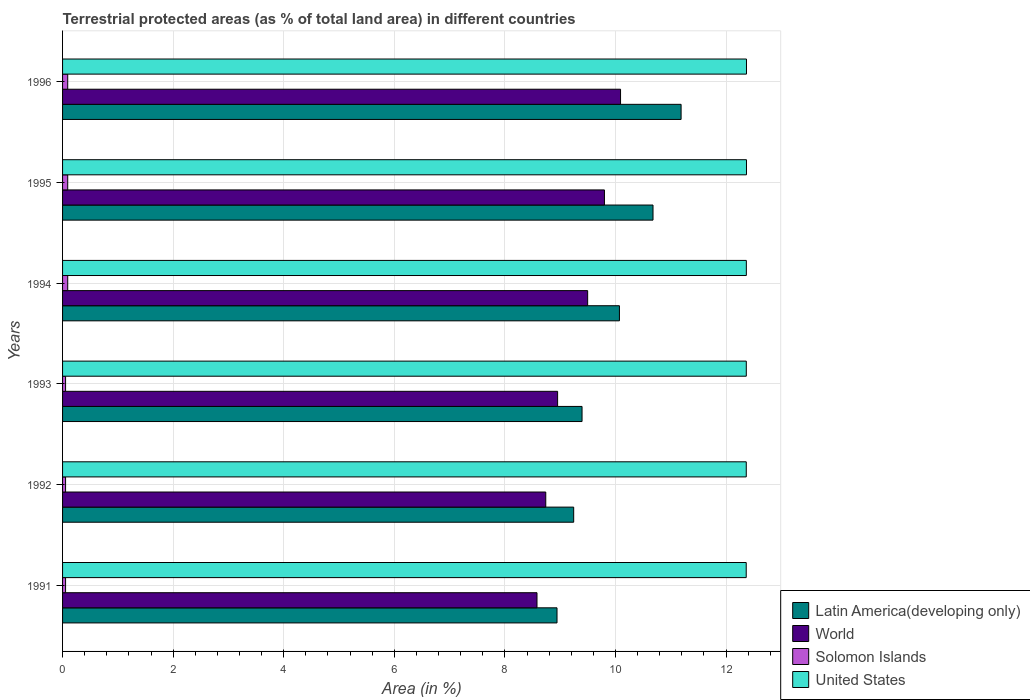How many different coloured bars are there?
Offer a terse response. 4. How many groups of bars are there?
Ensure brevity in your answer.  6. Are the number of bars per tick equal to the number of legend labels?
Provide a succinct answer. Yes. Are the number of bars on each tick of the Y-axis equal?
Offer a terse response. Yes. How many bars are there on the 6th tick from the top?
Provide a succinct answer. 4. What is the label of the 5th group of bars from the top?
Offer a terse response. 1992. What is the percentage of terrestrial protected land in United States in 1992?
Make the answer very short. 12.36. Across all years, what is the maximum percentage of terrestrial protected land in United States?
Offer a very short reply. 12.37. Across all years, what is the minimum percentage of terrestrial protected land in Latin America(developing only)?
Offer a very short reply. 8.94. What is the total percentage of terrestrial protected land in World in the graph?
Ensure brevity in your answer.  55.66. What is the difference between the percentage of terrestrial protected land in Latin America(developing only) in 1992 and that in 1993?
Give a very brief answer. -0.15. What is the difference between the percentage of terrestrial protected land in Solomon Islands in 1994 and the percentage of terrestrial protected land in Latin America(developing only) in 1993?
Make the answer very short. -9.3. What is the average percentage of terrestrial protected land in World per year?
Keep it short and to the point. 9.28. In the year 1994, what is the difference between the percentage of terrestrial protected land in Latin America(developing only) and percentage of terrestrial protected land in Solomon Islands?
Give a very brief answer. 9.98. In how many years, is the percentage of terrestrial protected land in World greater than 1.6 %?
Give a very brief answer. 6. What is the ratio of the percentage of terrestrial protected land in World in 1994 to that in 1995?
Offer a very short reply. 0.97. What is the difference between the highest and the second highest percentage of terrestrial protected land in Latin America(developing only)?
Keep it short and to the point. 0.51. What is the difference between the highest and the lowest percentage of terrestrial protected land in Latin America(developing only)?
Your response must be concise. 2.24. In how many years, is the percentage of terrestrial protected land in Solomon Islands greater than the average percentage of terrestrial protected land in Solomon Islands taken over all years?
Give a very brief answer. 3. What does the 2nd bar from the top in 1994 represents?
Ensure brevity in your answer.  Solomon Islands. What does the 4th bar from the bottom in 1996 represents?
Keep it short and to the point. United States. How many bars are there?
Provide a short and direct response. 24. Are all the bars in the graph horizontal?
Ensure brevity in your answer.  Yes. What is the difference between two consecutive major ticks on the X-axis?
Your answer should be very brief. 2. Are the values on the major ticks of X-axis written in scientific E-notation?
Make the answer very short. No. What is the title of the graph?
Offer a very short reply. Terrestrial protected areas (as % of total land area) in different countries. What is the label or title of the X-axis?
Your answer should be compact. Area (in %). What is the label or title of the Y-axis?
Your answer should be compact. Years. What is the Area (in %) in Latin America(developing only) in 1991?
Your response must be concise. 8.94. What is the Area (in %) of World in 1991?
Provide a succinct answer. 8.58. What is the Area (in %) of Solomon Islands in 1991?
Offer a very short reply. 0.05. What is the Area (in %) in United States in 1991?
Provide a succinct answer. 12.36. What is the Area (in %) of Latin America(developing only) in 1992?
Provide a short and direct response. 9.24. What is the Area (in %) of World in 1992?
Make the answer very short. 8.74. What is the Area (in %) in Solomon Islands in 1992?
Provide a short and direct response. 0.05. What is the Area (in %) of United States in 1992?
Your answer should be compact. 12.36. What is the Area (in %) of Latin America(developing only) in 1993?
Your answer should be very brief. 9.39. What is the Area (in %) in World in 1993?
Your response must be concise. 8.95. What is the Area (in %) in Solomon Islands in 1993?
Offer a very short reply. 0.05. What is the Area (in %) of United States in 1993?
Make the answer very short. 12.37. What is the Area (in %) of Latin America(developing only) in 1994?
Give a very brief answer. 10.07. What is the Area (in %) of World in 1994?
Your response must be concise. 9.5. What is the Area (in %) in Solomon Islands in 1994?
Ensure brevity in your answer.  0.09. What is the Area (in %) of United States in 1994?
Keep it short and to the point. 12.37. What is the Area (in %) of Latin America(developing only) in 1995?
Provide a short and direct response. 10.68. What is the Area (in %) in World in 1995?
Offer a terse response. 9.8. What is the Area (in %) of Solomon Islands in 1995?
Keep it short and to the point. 0.09. What is the Area (in %) in United States in 1995?
Make the answer very short. 12.37. What is the Area (in %) in Latin America(developing only) in 1996?
Give a very brief answer. 11.19. What is the Area (in %) of World in 1996?
Provide a short and direct response. 10.09. What is the Area (in %) in Solomon Islands in 1996?
Provide a short and direct response. 0.09. What is the Area (in %) in United States in 1996?
Keep it short and to the point. 12.37. Across all years, what is the maximum Area (in %) in Latin America(developing only)?
Offer a terse response. 11.19. Across all years, what is the maximum Area (in %) in World?
Keep it short and to the point. 10.09. Across all years, what is the maximum Area (in %) of Solomon Islands?
Ensure brevity in your answer.  0.09. Across all years, what is the maximum Area (in %) in United States?
Your answer should be very brief. 12.37. Across all years, what is the minimum Area (in %) of Latin America(developing only)?
Offer a terse response. 8.94. Across all years, what is the minimum Area (in %) in World?
Offer a terse response. 8.58. Across all years, what is the minimum Area (in %) of Solomon Islands?
Ensure brevity in your answer.  0.05. Across all years, what is the minimum Area (in %) in United States?
Your answer should be compact. 12.36. What is the total Area (in %) of Latin America(developing only) in the graph?
Provide a succinct answer. 59.52. What is the total Area (in %) in World in the graph?
Make the answer very short. 55.66. What is the total Area (in %) in Solomon Islands in the graph?
Make the answer very short. 0.44. What is the total Area (in %) of United States in the graph?
Offer a terse response. 74.2. What is the difference between the Area (in %) of Latin America(developing only) in 1991 and that in 1992?
Your response must be concise. -0.3. What is the difference between the Area (in %) in World in 1991 and that in 1992?
Your answer should be compact. -0.16. What is the difference between the Area (in %) of Solomon Islands in 1991 and that in 1992?
Make the answer very short. 0. What is the difference between the Area (in %) in United States in 1991 and that in 1992?
Your answer should be compact. -0. What is the difference between the Area (in %) in Latin America(developing only) in 1991 and that in 1993?
Your response must be concise. -0.45. What is the difference between the Area (in %) of World in 1991 and that in 1993?
Offer a terse response. -0.37. What is the difference between the Area (in %) in United States in 1991 and that in 1993?
Offer a terse response. -0. What is the difference between the Area (in %) in Latin America(developing only) in 1991 and that in 1994?
Offer a very short reply. -1.13. What is the difference between the Area (in %) in World in 1991 and that in 1994?
Ensure brevity in your answer.  -0.92. What is the difference between the Area (in %) in Solomon Islands in 1991 and that in 1994?
Make the answer very short. -0.04. What is the difference between the Area (in %) in United States in 1991 and that in 1994?
Provide a succinct answer. -0. What is the difference between the Area (in %) of Latin America(developing only) in 1991 and that in 1995?
Your answer should be very brief. -1.74. What is the difference between the Area (in %) of World in 1991 and that in 1995?
Offer a very short reply. -1.22. What is the difference between the Area (in %) in Solomon Islands in 1991 and that in 1995?
Provide a succinct answer. -0.04. What is the difference between the Area (in %) of United States in 1991 and that in 1995?
Keep it short and to the point. -0. What is the difference between the Area (in %) of Latin America(developing only) in 1991 and that in 1996?
Your answer should be compact. -2.24. What is the difference between the Area (in %) in World in 1991 and that in 1996?
Your answer should be compact. -1.51. What is the difference between the Area (in %) in Solomon Islands in 1991 and that in 1996?
Your answer should be very brief. -0.04. What is the difference between the Area (in %) of United States in 1991 and that in 1996?
Provide a succinct answer. -0. What is the difference between the Area (in %) in Latin America(developing only) in 1992 and that in 1993?
Make the answer very short. -0.15. What is the difference between the Area (in %) in World in 1992 and that in 1993?
Make the answer very short. -0.21. What is the difference between the Area (in %) of Solomon Islands in 1992 and that in 1993?
Your answer should be compact. 0. What is the difference between the Area (in %) in United States in 1992 and that in 1993?
Your answer should be compact. -0. What is the difference between the Area (in %) in Latin America(developing only) in 1992 and that in 1994?
Give a very brief answer. -0.83. What is the difference between the Area (in %) of World in 1992 and that in 1994?
Ensure brevity in your answer.  -0.76. What is the difference between the Area (in %) of Solomon Islands in 1992 and that in 1994?
Provide a short and direct response. -0.04. What is the difference between the Area (in %) of United States in 1992 and that in 1994?
Ensure brevity in your answer.  -0. What is the difference between the Area (in %) in Latin America(developing only) in 1992 and that in 1995?
Your response must be concise. -1.43. What is the difference between the Area (in %) of World in 1992 and that in 1995?
Ensure brevity in your answer.  -1.06. What is the difference between the Area (in %) of Solomon Islands in 1992 and that in 1995?
Offer a terse response. -0.04. What is the difference between the Area (in %) of United States in 1992 and that in 1995?
Provide a short and direct response. -0. What is the difference between the Area (in %) in Latin America(developing only) in 1992 and that in 1996?
Provide a short and direct response. -1.94. What is the difference between the Area (in %) in World in 1992 and that in 1996?
Give a very brief answer. -1.35. What is the difference between the Area (in %) of Solomon Islands in 1992 and that in 1996?
Your answer should be compact. -0.04. What is the difference between the Area (in %) of United States in 1992 and that in 1996?
Offer a very short reply. -0. What is the difference between the Area (in %) of Latin America(developing only) in 1993 and that in 1994?
Give a very brief answer. -0.68. What is the difference between the Area (in %) in World in 1993 and that in 1994?
Ensure brevity in your answer.  -0.54. What is the difference between the Area (in %) of Solomon Islands in 1993 and that in 1994?
Give a very brief answer. -0.04. What is the difference between the Area (in %) of United States in 1993 and that in 1994?
Give a very brief answer. -0. What is the difference between the Area (in %) of Latin America(developing only) in 1993 and that in 1995?
Ensure brevity in your answer.  -1.28. What is the difference between the Area (in %) of World in 1993 and that in 1995?
Offer a very short reply. -0.85. What is the difference between the Area (in %) in Solomon Islands in 1993 and that in 1995?
Provide a short and direct response. -0.04. What is the difference between the Area (in %) of United States in 1993 and that in 1995?
Offer a terse response. -0. What is the difference between the Area (in %) of Latin America(developing only) in 1993 and that in 1996?
Keep it short and to the point. -1.79. What is the difference between the Area (in %) of World in 1993 and that in 1996?
Your response must be concise. -1.14. What is the difference between the Area (in %) of Solomon Islands in 1993 and that in 1996?
Keep it short and to the point. -0.04. What is the difference between the Area (in %) in United States in 1993 and that in 1996?
Provide a short and direct response. -0. What is the difference between the Area (in %) of Latin America(developing only) in 1994 and that in 1995?
Offer a terse response. -0.61. What is the difference between the Area (in %) in World in 1994 and that in 1995?
Ensure brevity in your answer.  -0.3. What is the difference between the Area (in %) in United States in 1994 and that in 1995?
Make the answer very short. -0. What is the difference between the Area (in %) of Latin America(developing only) in 1994 and that in 1996?
Provide a succinct answer. -1.11. What is the difference between the Area (in %) of World in 1994 and that in 1996?
Offer a terse response. -0.59. What is the difference between the Area (in %) of United States in 1994 and that in 1996?
Offer a terse response. -0. What is the difference between the Area (in %) in Latin America(developing only) in 1995 and that in 1996?
Provide a succinct answer. -0.51. What is the difference between the Area (in %) in World in 1995 and that in 1996?
Give a very brief answer. -0.29. What is the difference between the Area (in %) of United States in 1995 and that in 1996?
Ensure brevity in your answer.  -0. What is the difference between the Area (in %) in Latin America(developing only) in 1991 and the Area (in %) in World in 1992?
Your answer should be very brief. 0.2. What is the difference between the Area (in %) of Latin America(developing only) in 1991 and the Area (in %) of Solomon Islands in 1992?
Offer a terse response. 8.89. What is the difference between the Area (in %) of Latin America(developing only) in 1991 and the Area (in %) of United States in 1992?
Provide a short and direct response. -3.42. What is the difference between the Area (in %) in World in 1991 and the Area (in %) in Solomon Islands in 1992?
Your answer should be very brief. 8.53. What is the difference between the Area (in %) in World in 1991 and the Area (in %) in United States in 1992?
Provide a succinct answer. -3.78. What is the difference between the Area (in %) of Solomon Islands in 1991 and the Area (in %) of United States in 1992?
Make the answer very short. -12.31. What is the difference between the Area (in %) in Latin America(developing only) in 1991 and the Area (in %) in World in 1993?
Provide a short and direct response. -0.01. What is the difference between the Area (in %) of Latin America(developing only) in 1991 and the Area (in %) of Solomon Islands in 1993?
Keep it short and to the point. 8.89. What is the difference between the Area (in %) in Latin America(developing only) in 1991 and the Area (in %) in United States in 1993?
Your answer should be very brief. -3.42. What is the difference between the Area (in %) in World in 1991 and the Area (in %) in Solomon Islands in 1993?
Keep it short and to the point. 8.53. What is the difference between the Area (in %) in World in 1991 and the Area (in %) in United States in 1993?
Keep it short and to the point. -3.79. What is the difference between the Area (in %) in Solomon Islands in 1991 and the Area (in %) in United States in 1993?
Keep it short and to the point. -12.31. What is the difference between the Area (in %) in Latin America(developing only) in 1991 and the Area (in %) in World in 1994?
Give a very brief answer. -0.55. What is the difference between the Area (in %) of Latin America(developing only) in 1991 and the Area (in %) of Solomon Islands in 1994?
Your response must be concise. 8.85. What is the difference between the Area (in %) of Latin America(developing only) in 1991 and the Area (in %) of United States in 1994?
Ensure brevity in your answer.  -3.42. What is the difference between the Area (in %) in World in 1991 and the Area (in %) in Solomon Islands in 1994?
Offer a very short reply. 8.49. What is the difference between the Area (in %) of World in 1991 and the Area (in %) of United States in 1994?
Provide a succinct answer. -3.79. What is the difference between the Area (in %) of Solomon Islands in 1991 and the Area (in %) of United States in 1994?
Provide a short and direct response. -12.31. What is the difference between the Area (in %) of Latin America(developing only) in 1991 and the Area (in %) of World in 1995?
Give a very brief answer. -0.86. What is the difference between the Area (in %) in Latin America(developing only) in 1991 and the Area (in %) in Solomon Islands in 1995?
Offer a very short reply. 8.85. What is the difference between the Area (in %) in Latin America(developing only) in 1991 and the Area (in %) in United States in 1995?
Offer a terse response. -3.43. What is the difference between the Area (in %) in World in 1991 and the Area (in %) in Solomon Islands in 1995?
Keep it short and to the point. 8.49. What is the difference between the Area (in %) of World in 1991 and the Area (in %) of United States in 1995?
Provide a succinct answer. -3.79. What is the difference between the Area (in %) in Solomon Islands in 1991 and the Area (in %) in United States in 1995?
Ensure brevity in your answer.  -12.31. What is the difference between the Area (in %) of Latin America(developing only) in 1991 and the Area (in %) of World in 1996?
Ensure brevity in your answer.  -1.15. What is the difference between the Area (in %) in Latin America(developing only) in 1991 and the Area (in %) in Solomon Islands in 1996?
Offer a terse response. 8.85. What is the difference between the Area (in %) of Latin America(developing only) in 1991 and the Area (in %) of United States in 1996?
Make the answer very short. -3.43. What is the difference between the Area (in %) in World in 1991 and the Area (in %) in Solomon Islands in 1996?
Give a very brief answer. 8.49. What is the difference between the Area (in %) of World in 1991 and the Area (in %) of United States in 1996?
Keep it short and to the point. -3.79. What is the difference between the Area (in %) in Solomon Islands in 1991 and the Area (in %) in United States in 1996?
Offer a terse response. -12.31. What is the difference between the Area (in %) in Latin America(developing only) in 1992 and the Area (in %) in World in 1993?
Give a very brief answer. 0.29. What is the difference between the Area (in %) in Latin America(developing only) in 1992 and the Area (in %) in Solomon Islands in 1993?
Provide a short and direct response. 9.19. What is the difference between the Area (in %) in Latin America(developing only) in 1992 and the Area (in %) in United States in 1993?
Provide a succinct answer. -3.12. What is the difference between the Area (in %) in World in 1992 and the Area (in %) in Solomon Islands in 1993?
Give a very brief answer. 8.68. What is the difference between the Area (in %) in World in 1992 and the Area (in %) in United States in 1993?
Offer a terse response. -3.63. What is the difference between the Area (in %) in Solomon Islands in 1992 and the Area (in %) in United States in 1993?
Offer a very short reply. -12.31. What is the difference between the Area (in %) of Latin America(developing only) in 1992 and the Area (in %) of World in 1994?
Your answer should be very brief. -0.25. What is the difference between the Area (in %) in Latin America(developing only) in 1992 and the Area (in %) in Solomon Islands in 1994?
Make the answer very short. 9.15. What is the difference between the Area (in %) in Latin America(developing only) in 1992 and the Area (in %) in United States in 1994?
Keep it short and to the point. -3.12. What is the difference between the Area (in %) of World in 1992 and the Area (in %) of Solomon Islands in 1994?
Offer a terse response. 8.65. What is the difference between the Area (in %) of World in 1992 and the Area (in %) of United States in 1994?
Your response must be concise. -3.63. What is the difference between the Area (in %) in Solomon Islands in 1992 and the Area (in %) in United States in 1994?
Your answer should be very brief. -12.31. What is the difference between the Area (in %) in Latin America(developing only) in 1992 and the Area (in %) in World in 1995?
Provide a short and direct response. -0.56. What is the difference between the Area (in %) in Latin America(developing only) in 1992 and the Area (in %) in Solomon Islands in 1995?
Your answer should be compact. 9.15. What is the difference between the Area (in %) of Latin America(developing only) in 1992 and the Area (in %) of United States in 1995?
Your answer should be compact. -3.13. What is the difference between the Area (in %) in World in 1992 and the Area (in %) in Solomon Islands in 1995?
Provide a short and direct response. 8.65. What is the difference between the Area (in %) of World in 1992 and the Area (in %) of United States in 1995?
Give a very brief answer. -3.63. What is the difference between the Area (in %) in Solomon Islands in 1992 and the Area (in %) in United States in 1995?
Make the answer very short. -12.31. What is the difference between the Area (in %) of Latin America(developing only) in 1992 and the Area (in %) of World in 1996?
Offer a terse response. -0.85. What is the difference between the Area (in %) in Latin America(developing only) in 1992 and the Area (in %) in Solomon Islands in 1996?
Provide a succinct answer. 9.15. What is the difference between the Area (in %) of Latin America(developing only) in 1992 and the Area (in %) of United States in 1996?
Offer a terse response. -3.13. What is the difference between the Area (in %) of World in 1992 and the Area (in %) of Solomon Islands in 1996?
Provide a short and direct response. 8.65. What is the difference between the Area (in %) in World in 1992 and the Area (in %) in United States in 1996?
Provide a short and direct response. -3.63. What is the difference between the Area (in %) in Solomon Islands in 1992 and the Area (in %) in United States in 1996?
Your answer should be very brief. -12.31. What is the difference between the Area (in %) of Latin America(developing only) in 1993 and the Area (in %) of World in 1994?
Provide a succinct answer. -0.1. What is the difference between the Area (in %) of Latin America(developing only) in 1993 and the Area (in %) of Solomon Islands in 1994?
Offer a terse response. 9.3. What is the difference between the Area (in %) of Latin America(developing only) in 1993 and the Area (in %) of United States in 1994?
Keep it short and to the point. -2.97. What is the difference between the Area (in %) in World in 1993 and the Area (in %) in Solomon Islands in 1994?
Make the answer very short. 8.86. What is the difference between the Area (in %) of World in 1993 and the Area (in %) of United States in 1994?
Offer a terse response. -3.41. What is the difference between the Area (in %) of Solomon Islands in 1993 and the Area (in %) of United States in 1994?
Your response must be concise. -12.31. What is the difference between the Area (in %) in Latin America(developing only) in 1993 and the Area (in %) in World in 1995?
Your response must be concise. -0.41. What is the difference between the Area (in %) of Latin America(developing only) in 1993 and the Area (in %) of Solomon Islands in 1995?
Your answer should be very brief. 9.3. What is the difference between the Area (in %) in Latin America(developing only) in 1993 and the Area (in %) in United States in 1995?
Ensure brevity in your answer.  -2.97. What is the difference between the Area (in %) in World in 1993 and the Area (in %) in Solomon Islands in 1995?
Offer a very short reply. 8.86. What is the difference between the Area (in %) in World in 1993 and the Area (in %) in United States in 1995?
Ensure brevity in your answer.  -3.42. What is the difference between the Area (in %) in Solomon Islands in 1993 and the Area (in %) in United States in 1995?
Keep it short and to the point. -12.31. What is the difference between the Area (in %) of Latin America(developing only) in 1993 and the Area (in %) of World in 1996?
Your response must be concise. -0.7. What is the difference between the Area (in %) in Latin America(developing only) in 1993 and the Area (in %) in Solomon Islands in 1996?
Offer a terse response. 9.3. What is the difference between the Area (in %) of Latin America(developing only) in 1993 and the Area (in %) of United States in 1996?
Offer a terse response. -2.97. What is the difference between the Area (in %) of World in 1993 and the Area (in %) of Solomon Islands in 1996?
Provide a short and direct response. 8.86. What is the difference between the Area (in %) of World in 1993 and the Area (in %) of United States in 1996?
Ensure brevity in your answer.  -3.42. What is the difference between the Area (in %) in Solomon Islands in 1993 and the Area (in %) in United States in 1996?
Provide a succinct answer. -12.31. What is the difference between the Area (in %) of Latin America(developing only) in 1994 and the Area (in %) of World in 1995?
Offer a terse response. 0.27. What is the difference between the Area (in %) of Latin America(developing only) in 1994 and the Area (in %) of Solomon Islands in 1995?
Offer a very short reply. 9.98. What is the difference between the Area (in %) in Latin America(developing only) in 1994 and the Area (in %) in United States in 1995?
Give a very brief answer. -2.3. What is the difference between the Area (in %) in World in 1994 and the Area (in %) in Solomon Islands in 1995?
Provide a succinct answer. 9.4. What is the difference between the Area (in %) in World in 1994 and the Area (in %) in United States in 1995?
Offer a terse response. -2.87. What is the difference between the Area (in %) in Solomon Islands in 1994 and the Area (in %) in United States in 1995?
Provide a succinct answer. -12.28. What is the difference between the Area (in %) of Latin America(developing only) in 1994 and the Area (in %) of World in 1996?
Offer a terse response. -0.02. What is the difference between the Area (in %) in Latin America(developing only) in 1994 and the Area (in %) in Solomon Islands in 1996?
Ensure brevity in your answer.  9.98. What is the difference between the Area (in %) in Latin America(developing only) in 1994 and the Area (in %) in United States in 1996?
Your answer should be very brief. -2.3. What is the difference between the Area (in %) in World in 1994 and the Area (in %) in Solomon Islands in 1996?
Give a very brief answer. 9.4. What is the difference between the Area (in %) in World in 1994 and the Area (in %) in United States in 1996?
Offer a very short reply. -2.87. What is the difference between the Area (in %) of Solomon Islands in 1994 and the Area (in %) of United States in 1996?
Your answer should be compact. -12.28. What is the difference between the Area (in %) of Latin America(developing only) in 1995 and the Area (in %) of World in 1996?
Offer a very short reply. 0.59. What is the difference between the Area (in %) in Latin America(developing only) in 1995 and the Area (in %) in Solomon Islands in 1996?
Give a very brief answer. 10.59. What is the difference between the Area (in %) of Latin America(developing only) in 1995 and the Area (in %) of United States in 1996?
Give a very brief answer. -1.69. What is the difference between the Area (in %) of World in 1995 and the Area (in %) of Solomon Islands in 1996?
Offer a very short reply. 9.71. What is the difference between the Area (in %) of World in 1995 and the Area (in %) of United States in 1996?
Your response must be concise. -2.57. What is the difference between the Area (in %) of Solomon Islands in 1995 and the Area (in %) of United States in 1996?
Offer a terse response. -12.28. What is the average Area (in %) in Latin America(developing only) per year?
Give a very brief answer. 9.92. What is the average Area (in %) of World per year?
Your response must be concise. 9.28. What is the average Area (in %) in Solomon Islands per year?
Offer a terse response. 0.07. What is the average Area (in %) in United States per year?
Make the answer very short. 12.37. In the year 1991, what is the difference between the Area (in %) in Latin America(developing only) and Area (in %) in World?
Ensure brevity in your answer.  0.36. In the year 1991, what is the difference between the Area (in %) of Latin America(developing only) and Area (in %) of Solomon Islands?
Your response must be concise. 8.89. In the year 1991, what is the difference between the Area (in %) of Latin America(developing only) and Area (in %) of United States?
Provide a short and direct response. -3.42. In the year 1991, what is the difference between the Area (in %) of World and Area (in %) of Solomon Islands?
Give a very brief answer. 8.53. In the year 1991, what is the difference between the Area (in %) of World and Area (in %) of United States?
Keep it short and to the point. -3.78. In the year 1991, what is the difference between the Area (in %) in Solomon Islands and Area (in %) in United States?
Your answer should be compact. -12.31. In the year 1992, what is the difference between the Area (in %) of Latin America(developing only) and Area (in %) of World?
Offer a very short reply. 0.5. In the year 1992, what is the difference between the Area (in %) of Latin America(developing only) and Area (in %) of Solomon Islands?
Your response must be concise. 9.19. In the year 1992, what is the difference between the Area (in %) in Latin America(developing only) and Area (in %) in United States?
Provide a succinct answer. -3.12. In the year 1992, what is the difference between the Area (in %) in World and Area (in %) in Solomon Islands?
Offer a very short reply. 8.68. In the year 1992, what is the difference between the Area (in %) in World and Area (in %) in United States?
Give a very brief answer. -3.63. In the year 1992, what is the difference between the Area (in %) of Solomon Islands and Area (in %) of United States?
Provide a succinct answer. -12.31. In the year 1993, what is the difference between the Area (in %) of Latin America(developing only) and Area (in %) of World?
Provide a succinct answer. 0.44. In the year 1993, what is the difference between the Area (in %) in Latin America(developing only) and Area (in %) in Solomon Islands?
Your answer should be compact. 9.34. In the year 1993, what is the difference between the Area (in %) of Latin America(developing only) and Area (in %) of United States?
Your answer should be compact. -2.97. In the year 1993, what is the difference between the Area (in %) of World and Area (in %) of Solomon Islands?
Ensure brevity in your answer.  8.9. In the year 1993, what is the difference between the Area (in %) of World and Area (in %) of United States?
Your answer should be very brief. -3.41. In the year 1993, what is the difference between the Area (in %) in Solomon Islands and Area (in %) in United States?
Ensure brevity in your answer.  -12.31. In the year 1994, what is the difference between the Area (in %) of Latin America(developing only) and Area (in %) of World?
Offer a very short reply. 0.57. In the year 1994, what is the difference between the Area (in %) in Latin America(developing only) and Area (in %) in Solomon Islands?
Make the answer very short. 9.98. In the year 1994, what is the difference between the Area (in %) in Latin America(developing only) and Area (in %) in United States?
Your answer should be compact. -2.29. In the year 1994, what is the difference between the Area (in %) of World and Area (in %) of Solomon Islands?
Ensure brevity in your answer.  9.4. In the year 1994, what is the difference between the Area (in %) in World and Area (in %) in United States?
Your response must be concise. -2.87. In the year 1994, what is the difference between the Area (in %) in Solomon Islands and Area (in %) in United States?
Offer a terse response. -12.27. In the year 1995, what is the difference between the Area (in %) of Latin America(developing only) and Area (in %) of World?
Provide a short and direct response. 0.88. In the year 1995, what is the difference between the Area (in %) of Latin America(developing only) and Area (in %) of Solomon Islands?
Offer a very short reply. 10.59. In the year 1995, what is the difference between the Area (in %) in Latin America(developing only) and Area (in %) in United States?
Your answer should be very brief. -1.69. In the year 1995, what is the difference between the Area (in %) of World and Area (in %) of Solomon Islands?
Make the answer very short. 9.71. In the year 1995, what is the difference between the Area (in %) of World and Area (in %) of United States?
Ensure brevity in your answer.  -2.57. In the year 1995, what is the difference between the Area (in %) of Solomon Islands and Area (in %) of United States?
Make the answer very short. -12.28. In the year 1996, what is the difference between the Area (in %) in Latin America(developing only) and Area (in %) in World?
Keep it short and to the point. 1.09. In the year 1996, what is the difference between the Area (in %) of Latin America(developing only) and Area (in %) of Solomon Islands?
Make the answer very short. 11.09. In the year 1996, what is the difference between the Area (in %) in Latin America(developing only) and Area (in %) in United States?
Provide a short and direct response. -1.18. In the year 1996, what is the difference between the Area (in %) of World and Area (in %) of Solomon Islands?
Provide a short and direct response. 10. In the year 1996, what is the difference between the Area (in %) in World and Area (in %) in United States?
Offer a terse response. -2.28. In the year 1996, what is the difference between the Area (in %) in Solomon Islands and Area (in %) in United States?
Your answer should be compact. -12.28. What is the ratio of the Area (in %) in Latin America(developing only) in 1991 to that in 1992?
Offer a terse response. 0.97. What is the ratio of the Area (in %) of World in 1991 to that in 1992?
Offer a very short reply. 0.98. What is the ratio of the Area (in %) of United States in 1991 to that in 1992?
Offer a very short reply. 1. What is the ratio of the Area (in %) of Latin America(developing only) in 1991 to that in 1993?
Make the answer very short. 0.95. What is the ratio of the Area (in %) of World in 1991 to that in 1993?
Provide a succinct answer. 0.96. What is the ratio of the Area (in %) of United States in 1991 to that in 1993?
Keep it short and to the point. 1. What is the ratio of the Area (in %) in Latin America(developing only) in 1991 to that in 1994?
Make the answer very short. 0.89. What is the ratio of the Area (in %) of World in 1991 to that in 1994?
Offer a very short reply. 0.9. What is the ratio of the Area (in %) in Solomon Islands in 1991 to that in 1994?
Keep it short and to the point. 0.58. What is the ratio of the Area (in %) in Latin America(developing only) in 1991 to that in 1995?
Ensure brevity in your answer.  0.84. What is the ratio of the Area (in %) in World in 1991 to that in 1995?
Keep it short and to the point. 0.88. What is the ratio of the Area (in %) in Solomon Islands in 1991 to that in 1995?
Offer a very short reply. 0.58. What is the ratio of the Area (in %) of United States in 1991 to that in 1995?
Your answer should be compact. 1. What is the ratio of the Area (in %) of Latin America(developing only) in 1991 to that in 1996?
Offer a very short reply. 0.8. What is the ratio of the Area (in %) of World in 1991 to that in 1996?
Your answer should be compact. 0.85. What is the ratio of the Area (in %) in Solomon Islands in 1991 to that in 1996?
Offer a terse response. 0.58. What is the ratio of the Area (in %) of United States in 1991 to that in 1996?
Ensure brevity in your answer.  1. What is the ratio of the Area (in %) of Latin America(developing only) in 1992 to that in 1993?
Offer a terse response. 0.98. What is the ratio of the Area (in %) of World in 1992 to that in 1993?
Your response must be concise. 0.98. What is the ratio of the Area (in %) in Latin America(developing only) in 1992 to that in 1994?
Provide a short and direct response. 0.92. What is the ratio of the Area (in %) in World in 1992 to that in 1994?
Your response must be concise. 0.92. What is the ratio of the Area (in %) in Solomon Islands in 1992 to that in 1994?
Give a very brief answer. 0.58. What is the ratio of the Area (in %) in Latin America(developing only) in 1992 to that in 1995?
Your answer should be compact. 0.87. What is the ratio of the Area (in %) in World in 1992 to that in 1995?
Provide a succinct answer. 0.89. What is the ratio of the Area (in %) of Solomon Islands in 1992 to that in 1995?
Your response must be concise. 0.58. What is the ratio of the Area (in %) in Latin America(developing only) in 1992 to that in 1996?
Provide a succinct answer. 0.83. What is the ratio of the Area (in %) in World in 1992 to that in 1996?
Offer a terse response. 0.87. What is the ratio of the Area (in %) in Solomon Islands in 1992 to that in 1996?
Make the answer very short. 0.58. What is the ratio of the Area (in %) of Latin America(developing only) in 1993 to that in 1994?
Your answer should be compact. 0.93. What is the ratio of the Area (in %) of World in 1993 to that in 1994?
Offer a very short reply. 0.94. What is the ratio of the Area (in %) of Solomon Islands in 1993 to that in 1994?
Your response must be concise. 0.58. What is the ratio of the Area (in %) of Latin America(developing only) in 1993 to that in 1995?
Provide a succinct answer. 0.88. What is the ratio of the Area (in %) in World in 1993 to that in 1995?
Ensure brevity in your answer.  0.91. What is the ratio of the Area (in %) in Solomon Islands in 1993 to that in 1995?
Give a very brief answer. 0.58. What is the ratio of the Area (in %) in United States in 1993 to that in 1995?
Your answer should be very brief. 1. What is the ratio of the Area (in %) in Latin America(developing only) in 1993 to that in 1996?
Keep it short and to the point. 0.84. What is the ratio of the Area (in %) of World in 1993 to that in 1996?
Ensure brevity in your answer.  0.89. What is the ratio of the Area (in %) of Solomon Islands in 1993 to that in 1996?
Your response must be concise. 0.58. What is the ratio of the Area (in %) of Latin America(developing only) in 1994 to that in 1995?
Offer a very short reply. 0.94. What is the ratio of the Area (in %) in World in 1994 to that in 1995?
Give a very brief answer. 0.97. What is the ratio of the Area (in %) of Solomon Islands in 1994 to that in 1995?
Your response must be concise. 1. What is the ratio of the Area (in %) of United States in 1994 to that in 1995?
Offer a terse response. 1. What is the ratio of the Area (in %) in Latin America(developing only) in 1994 to that in 1996?
Keep it short and to the point. 0.9. What is the ratio of the Area (in %) of World in 1994 to that in 1996?
Your response must be concise. 0.94. What is the ratio of the Area (in %) of Latin America(developing only) in 1995 to that in 1996?
Your answer should be compact. 0.95. What is the ratio of the Area (in %) in World in 1995 to that in 1996?
Offer a very short reply. 0.97. What is the ratio of the Area (in %) in Solomon Islands in 1995 to that in 1996?
Your answer should be very brief. 1. What is the ratio of the Area (in %) of United States in 1995 to that in 1996?
Provide a succinct answer. 1. What is the difference between the highest and the second highest Area (in %) of Latin America(developing only)?
Offer a terse response. 0.51. What is the difference between the highest and the second highest Area (in %) of World?
Keep it short and to the point. 0.29. What is the difference between the highest and the second highest Area (in %) in Solomon Islands?
Offer a terse response. 0. What is the difference between the highest and the lowest Area (in %) of Latin America(developing only)?
Offer a terse response. 2.24. What is the difference between the highest and the lowest Area (in %) of World?
Your answer should be very brief. 1.51. What is the difference between the highest and the lowest Area (in %) of Solomon Islands?
Ensure brevity in your answer.  0.04. What is the difference between the highest and the lowest Area (in %) in United States?
Give a very brief answer. 0. 